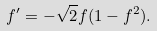<formula> <loc_0><loc_0><loc_500><loc_500>f ^ { \prime } = - \sqrt { 2 } f ( 1 - f ^ { 2 } ) .</formula> 